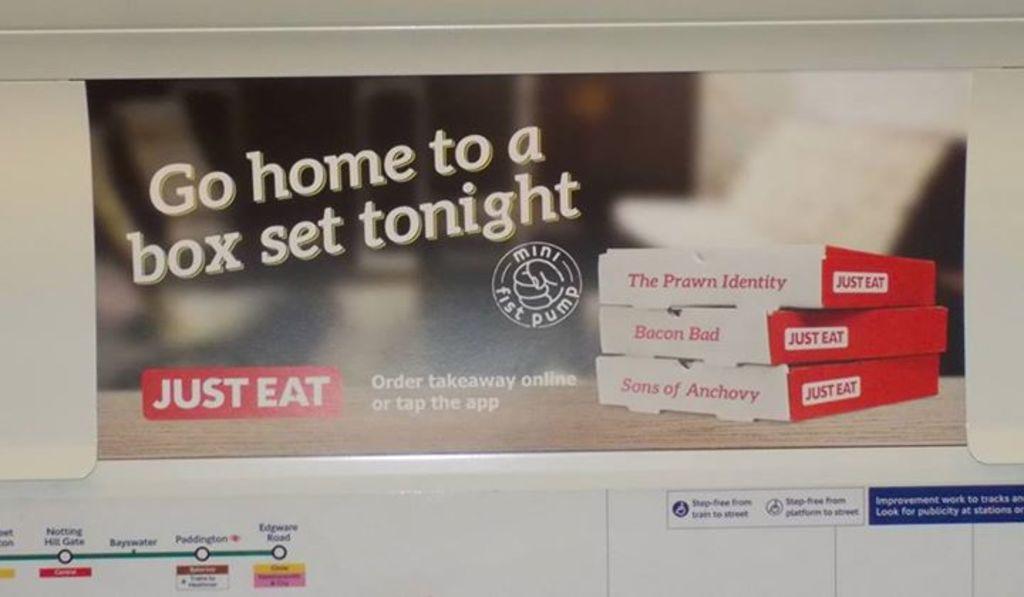Go home to what?
Give a very brief answer. Box set. What does the box in the middle say about bacon?
Keep it short and to the point. Bad. 